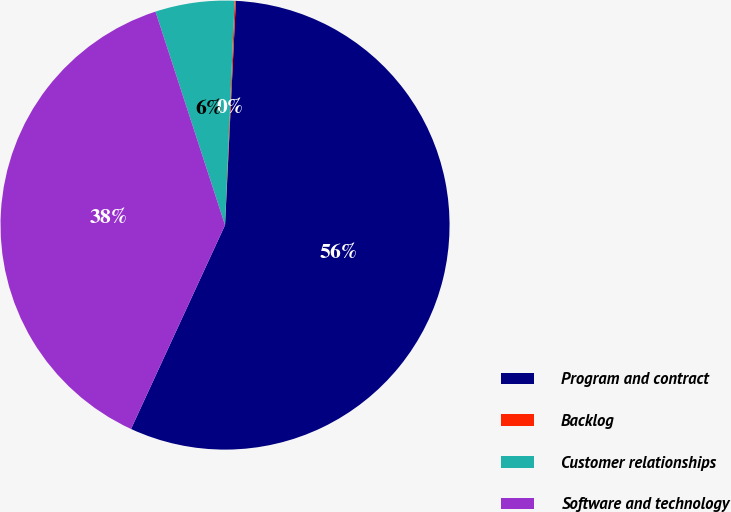Convert chart to OTSL. <chart><loc_0><loc_0><loc_500><loc_500><pie_chart><fcel>Program and contract<fcel>Backlog<fcel>Customer relationships<fcel>Software and technology<nl><fcel>56.11%<fcel>0.09%<fcel>5.69%<fcel>38.11%<nl></chart> 